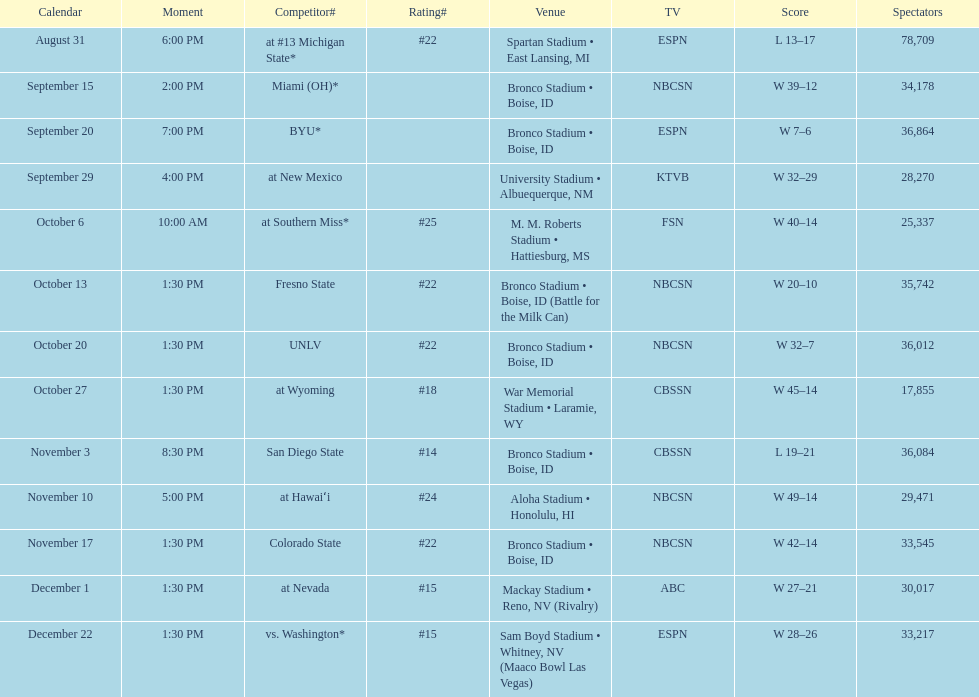Did the broncos on september 29th win by less than 5 points? Yes. 